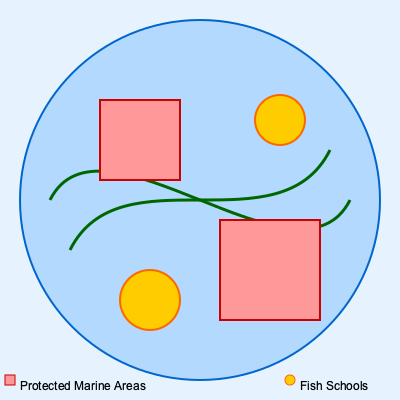Based on the sonar map provided, which area would be the most suitable for sustainable fishing while respecting protected marine zones? To determine the most suitable area for sustainable fishing while respecting protected marine zones, we need to analyze the sonar map step-by-step:

1. Identify the elements in the map:
   - The blue circle represents the fishing area.
   - Red squares indicate protected marine areas.
   - Yellow circles show fish schools.
   - Green curved lines represent underwater topography.

2. Locate the protected marine areas:
   - There are two red squares, one in the upper left quadrant and one in the lower right quadrant.

3. Find the fish schools:
   - Two yellow circles represent fish schools, one in the lower left quadrant and one in the upper right quadrant.

4. Consider the underwater topography:
   - The green lines suggest a varied underwater landscape, which can be beneficial for fish habitats.

5. Evaluate potential fishing locations:
   - The fish school in the lower left quadrant (coordinates approximately (150, 300)) is not near any protected areas and is close to interesting underwater features.
   - The fish school in the upper right quadrant (coordinates approximately (280, 120)) is also not in a protected area but is closer to one.

6. Choose the best location:
   - The fish school in the lower left quadrant offers the best balance of distance from protected areas and proximity to favorable underwater topography.

Therefore, the most suitable area for sustainable fishing while respecting protected marine zones is the lower left quadrant, centered around the fish school at approximately (150, 300).
Answer: Lower left quadrant, around coordinates (150, 300) 